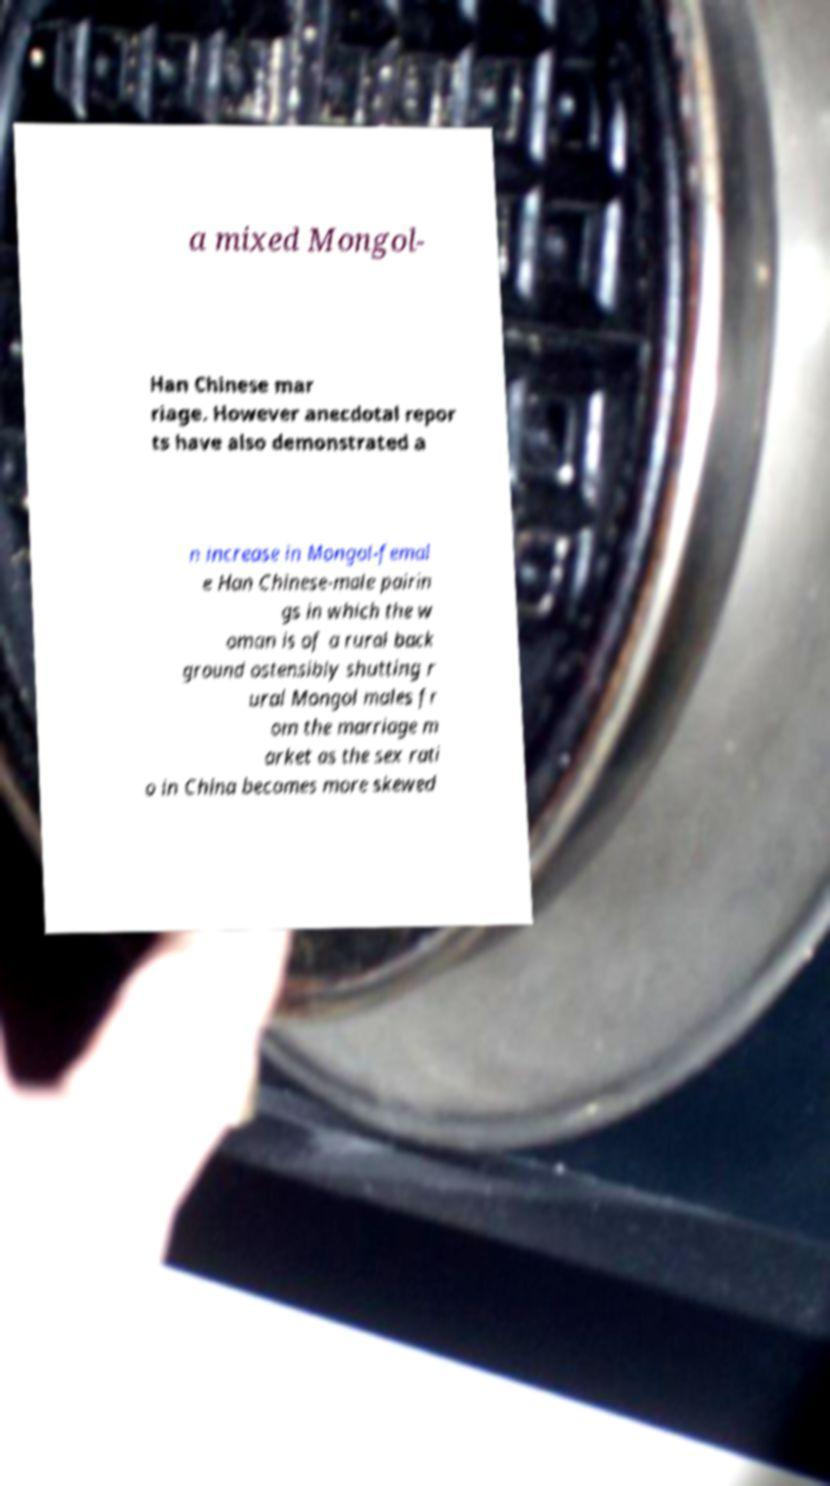Please read and relay the text visible in this image. What does it say? a mixed Mongol- Han Chinese mar riage. However anecdotal repor ts have also demonstrated a n increase in Mongol-femal e Han Chinese-male pairin gs in which the w oman is of a rural back ground ostensibly shutting r ural Mongol males fr om the marriage m arket as the sex rati o in China becomes more skewed 